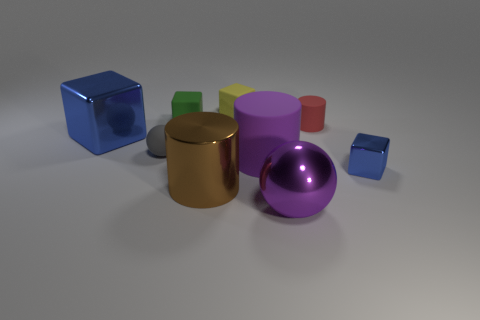Subtract 2 blocks. How many blocks are left? 2 Subtract all yellow cubes. How many cubes are left? 3 Subtract all rubber cylinders. How many cylinders are left? 1 Add 1 small green rubber things. How many objects exist? 10 Subtract all brown cubes. Subtract all green spheres. How many cubes are left? 4 Subtract all cylinders. How many objects are left? 6 Add 9 large blue things. How many large blue things are left? 10 Add 8 small yellow objects. How many small yellow objects exist? 9 Subtract 0 yellow cylinders. How many objects are left? 9 Subtract all yellow matte things. Subtract all small red cylinders. How many objects are left? 7 